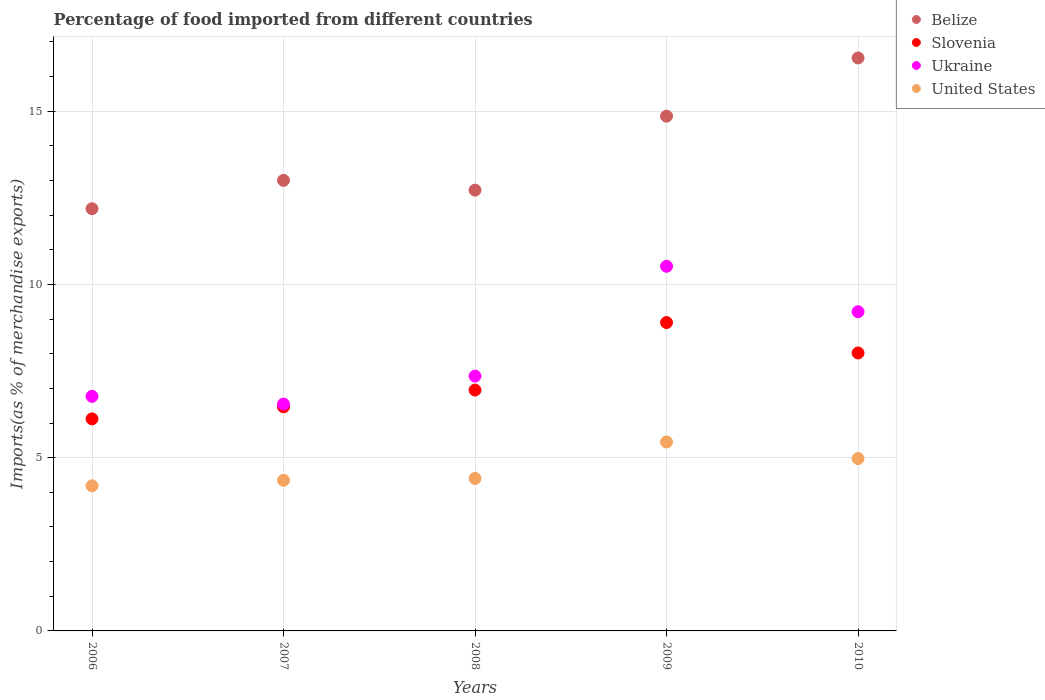Is the number of dotlines equal to the number of legend labels?
Provide a succinct answer. Yes. What is the percentage of imports to different countries in Ukraine in 2007?
Ensure brevity in your answer.  6.55. Across all years, what is the maximum percentage of imports to different countries in Slovenia?
Your answer should be compact. 8.9. Across all years, what is the minimum percentage of imports to different countries in Ukraine?
Ensure brevity in your answer.  6.55. What is the total percentage of imports to different countries in Belize in the graph?
Provide a short and direct response. 69.3. What is the difference between the percentage of imports to different countries in United States in 2006 and that in 2008?
Ensure brevity in your answer.  -0.21. What is the difference between the percentage of imports to different countries in Slovenia in 2006 and the percentage of imports to different countries in Ukraine in 2008?
Provide a succinct answer. -1.24. What is the average percentage of imports to different countries in Ukraine per year?
Provide a succinct answer. 8.08. In the year 2009, what is the difference between the percentage of imports to different countries in Ukraine and percentage of imports to different countries in Slovenia?
Provide a short and direct response. 1.62. What is the ratio of the percentage of imports to different countries in Belize in 2007 to that in 2010?
Your answer should be compact. 0.79. Is the difference between the percentage of imports to different countries in Ukraine in 2006 and 2008 greater than the difference between the percentage of imports to different countries in Slovenia in 2006 and 2008?
Offer a terse response. Yes. What is the difference between the highest and the second highest percentage of imports to different countries in Ukraine?
Offer a terse response. 1.31. What is the difference between the highest and the lowest percentage of imports to different countries in United States?
Give a very brief answer. 1.26. In how many years, is the percentage of imports to different countries in Belize greater than the average percentage of imports to different countries in Belize taken over all years?
Offer a very short reply. 2. Is the sum of the percentage of imports to different countries in United States in 2006 and 2007 greater than the maximum percentage of imports to different countries in Ukraine across all years?
Make the answer very short. No. Is the percentage of imports to different countries in United States strictly greater than the percentage of imports to different countries in Ukraine over the years?
Offer a very short reply. No. Are the values on the major ticks of Y-axis written in scientific E-notation?
Your answer should be very brief. No. How many legend labels are there?
Your answer should be very brief. 4. How are the legend labels stacked?
Make the answer very short. Vertical. What is the title of the graph?
Your answer should be compact. Percentage of food imported from different countries. What is the label or title of the Y-axis?
Provide a succinct answer. Imports(as % of merchandise exports). What is the Imports(as % of merchandise exports) of Belize in 2006?
Provide a short and direct response. 12.18. What is the Imports(as % of merchandise exports) in Slovenia in 2006?
Your answer should be very brief. 6.12. What is the Imports(as % of merchandise exports) of Ukraine in 2006?
Keep it short and to the point. 6.77. What is the Imports(as % of merchandise exports) in United States in 2006?
Keep it short and to the point. 4.19. What is the Imports(as % of merchandise exports) in Belize in 2007?
Give a very brief answer. 13. What is the Imports(as % of merchandise exports) of Slovenia in 2007?
Your answer should be very brief. 6.47. What is the Imports(as % of merchandise exports) in Ukraine in 2007?
Offer a very short reply. 6.55. What is the Imports(as % of merchandise exports) of United States in 2007?
Your answer should be very brief. 4.35. What is the Imports(as % of merchandise exports) in Belize in 2008?
Keep it short and to the point. 12.72. What is the Imports(as % of merchandise exports) in Slovenia in 2008?
Ensure brevity in your answer.  6.95. What is the Imports(as % of merchandise exports) in Ukraine in 2008?
Give a very brief answer. 7.35. What is the Imports(as % of merchandise exports) of United States in 2008?
Give a very brief answer. 4.4. What is the Imports(as % of merchandise exports) in Belize in 2009?
Your answer should be very brief. 14.86. What is the Imports(as % of merchandise exports) of Slovenia in 2009?
Make the answer very short. 8.9. What is the Imports(as % of merchandise exports) of Ukraine in 2009?
Ensure brevity in your answer.  10.52. What is the Imports(as % of merchandise exports) of United States in 2009?
Give a very brief answer. 5.45. What is the Imports(as % of merchandise exports) of Belize in 2010?
Your response must be concise. 16.54. What is the Imports(as % of merchandise exports) of Slovenia in 2010?
Keep it short and to the point. 8.02. What is the Imports(as % of merchandise exports) of Ukraine in 2010?
Provide a succinct answer. 9.21. What is the Imports(as % of merchandise exports) in United States in 2010?
Provide a succinct answer. 4.97. Across all years, what is the maximum Imports(as % of merchandise exports) in Belize?
Provide a succinct answer. 16.54. Across all years, what is the maximum Imports(as % of merchandise exports) in Slovenia?
Offer a very short reply. 8.9. Across all years, what is the maximum Imports(as % of merchandise exports) in Ukraine?
Your response must be concise. 10.52. Across all years, what is the maximum Imports(as % of merchandise exports) of United States?
Keep it short and to the point. 5.45. Across all years, what is the minimum Imports(as % of merchandise exports) in Belize?
Your answer should be very brief. 12.18. Across all years, what is the minimum Imports(as % of merchandise exports) in Slovenia?
Offer a terse response. 6.12. Across all years, what is the minimum Imports(as % of merchandise exports) in Ukraine?
Offer a terse response. 6.55. Across all years, what is the minimum Imports(as % of merchandise exports) in United States?
Give a very brief answer. 4.19. What is the total Imports(as % of merchandise exports) in Belize in the graph?
Your response must be concise. 69.3. What is the total Imports(as % of merchandise exports) of Slovenia in the graph?
Ensure brevity in your answer.  36.46. What is the total Imports(as % of merchandise exports) in Ukraine in the graph?
Ensure brevity in your answer.  40.41. What is the total Imports(as % of merchandise exports) in United States in the graph?
Offer a terse response. 23.36. What is the difference between the Imports(as % of merchandise exports) in Belize in 2006 and that in 2007?
Give a very brief answer. -0.82. What is the difference between the Imports(as % of merchandise exports) in Slovenia in 2006 and that in 2007?
Your answer should be compact. -0.35. What is the difference between the Imports(as % of merchandise exports) of Ukraine in 2006 and that in 2007?
Your answer should be very brief. 0.22. What is the difference between the Imports(as % of merchandise exports) in United States in 2006 and that in 2007?
Ensure brevity in your answer.  -0.16. What is the difference between the Imports(as % of merchandise exports) in Belize in 2006 and that in 2008?
Provide a short and direct response. -0.54. What is the difference between the Imports(as % of merchandise exports) in Slovenia in 2006 and that in 2008?
Ensure brevity in your answer.  -0.83. What is the difference between the Imports(as % of merchandise exports) of Ukraine in 2006 and that in 2008?
Your answer should be compact. -0.58. What is the difference between the Imports(as % of merchandise exports) in United States in 2006 and that in 2008?
Provide a short and direct response. -0.21. What is the difference between the Imports(as % of merchandise exports) in Belize in 2006 and that in 2009?
Offer a terse response. -2.67. What is the difference between the Imports(as % of merchandise exports) in Slovenia in 2006 and that in 2009?
Offer a terse response. -2.78. What is the difference between the Imports(as % of merchandise exports) of Ukraine in 2006 and that in 2009?
Your answer should be compact. -3.75. What is the difference between the Imports(as % of merchandise exports) in United States in 2006 and that in 2009?
Offer a very short reply. -1.26. What is the difference between the Imports(as % of merchandise exports) of Belize in 2006 and that in 2010?
Offer a terse response. -4.35. What is the difference between the Imports(as % of merchandise exports) of Slovenia in 2006 and that in 2010?
Ensure brevity in your answer.  -1.9. What is the difference between the Imports(as % of merchandise exports) in Ukraine in 2006 and that in 2010?
Your answer should be compact. -2.44. What is the difference between the Imports(as % of merchandise exports) of United States in 2006 and that in 2010?
Provide a short and direct response. -0.79. What is the difference between the Imports(as % of merchandise exports) of Belize in 2007 and that in 2008?
Provide a short and direct response. 0.28. What is the difference between the Imports(as % of merchandise exports) of Slovenia in 2007 and that in 2008?
Your response must be concise. -0.48. What is the difference between the Imports(as % of merchandise exports) in Ukraine in 2007 and that in 2008?
Offer a very short reply. -0.81. What is the difference between the Imports(as % of merchandise exports) in United States in 2007 and that in 2008?
Offer a terse response. -0.05. What is the difference between the Imports(as % of merchandise exports) of Belize in 2007 and that in 2009?
Your response must be concise. -1.85. What is the difference between the Imports(as % of merchandise exports) in Slovenia in 2007 and that in 2009?
Make the answer very short. -2.43. What is the difference between the Imports(as % of merchandise exports) of Ukraine in 2007 and that in 2009?
Offer a very short reply. -3.98. What is the difference between the Imports(as % of merchandise exports) in United States in 2007 and that in 2009?
Give a very brief answer. -1.1. What is the difference between the Imports(as % of merchandise exports) in Belize in 2007 and that in 2010?
Provide a short and direct response. -3.53. What is the difference between the Imports(as % of merchandise exports) in Slovenia in 2007 and that in 2010?
Offer a terse response. -1.56. What is the difference between the Imports(as % of merchandise exports) in Ukraine in 2007 and that in 2010?
Give a very brief answer. -2.67. What is the difference between the Imports(as % of merchandise exports) of United States in 2007 and that in 2010?
Your answer should be compact. -0.63. What is the difference between the Imports(as % of merchandise exports) of Belize in 2008 and that in 2009?
Provide a short and direct response. -2.13. What is the difference between the Imports(as % of merchandise exports) of Slovenia in 2008 and that in 2009?
Provide a succinct answer. -1.95. What is the difference between the Imports(as % of merchandise exports) of Ukraine in 2008 and that in 2009?
Provide a short and direct response. -3.17. What is the difference between the Imports(as % of merchandise exports) in United States in 2008 and that in 2009?
Your answer should be compact. -1.05. What is the difference between the Imports(as % of merchandise exports) in Belize in 2008 and that in 2010?
Your response must be concise. -3.81. What is the difference between the Imports(as % of merchandise exports) of Slovenia in 2008 and that in 2010?
Ensure brevity in your answer.  -1.07. What is the difference between the Imports(as % of merchandise exports) in Ukraine in 2008 and that in 2010?
Make the answer very short. -1.86. What is the difference between the Imports(as % of merchandise exports) in United States in 2008 and that in 2010?
Offer a very short reply. -0.57. What is the difference between the Imports(as % of merchandise exports) of Belize in 2009 and that in 2010?
Your answer should be compact. -1.68. What is the difference between the Imports(as % of merchandise exports) of Slovenia in 2009 and that in 2010?
Offer a very short reply. 0.88. What is the difference between the Imports(as % of merchandise exports) of Ukraine in 2009 and that in 2010?
Ensure brevity in your answer.  1.31. What is the difference between the Imports(as % of merchandise exports) in United States in 2009 and that in 2010?
Provide a succinct answer. 0.48. What is the difference between the Imports(as % of merchandise exports) in Belize in 2006 and the Imports(as % of merchandise exports) in Slovenia in 2007?
Provide a succinct answer. 5.72. What is the difference between the Imports(as % of merchandise exports) of Belize in 2006 and the Imports(as % of merchandise exports) of Ukraine in 2007?
Keep it short and to the point. 5.64. What is the difference between the Imports(as % of merchandise exports) in Belize in 2006 and the Imports(as % of merchandise exports) in United States in 2007?
Provide a short and direct response. 7.84. What is the difference between the Imports(as % of merchandise exports) of Slovenia in 2006 and the Imports(as % of merchandise exports) of Ukraine in 2007?
Your answer should be very brief. -0.43. What is the difference between the Imports(as % of merchandise exports) of Slovenia in 2006 and the Imports(as % of merchandise exports) of United States in 2007?
Offer a terse response. 1.77. What is the difference between the Imports(as % of merchandise exports) of Ukraine in 2006 and the Imports(as % of merchandise exports) of United States in 2007?
Offer a terse response. 2.42. What is the difference between the Imports(as % of merchandise exports) in Belize in 2006 and the Imports(as % of merchandise exports) in Slovenia in 2008?
Offer a very short reply. 5.23. What is the difference between the Imports(as % of merchandise exports) in Belize in 2006 and the Imports(as % of merchandise exports) in Ukraine in 2008?
Give a very brief answer. 4.83. What is the difference between the Imports(as % of merchandise exports) of Belize in 2006 and the Imports(as % of merchandise exports) of United States in 2008?
Provide a short and direct response. 7.78. What is the difference between the Imports(as % of merchandise exports) in Slovenia in 2006 and the Imports(as % of merchandise exports) in Ukraine in 2008?
Your answer should be very brief. -1.24. What is the difference between the Imports(as % of merchandise exports) of Slovenia in 2006 and the Imports(as % of merchandise exports) of United States in 2008?
Provide a succinct answer. 1.72. What is the difference between the Imports(as % of merchandise exports) in Ukraine in 2006 and the Imports(as % of merchandise exports) in United States in 2008?
Your answer should be very brief. 2.37. What is the difference between the Imports(as % of merchandise exports) in Belize in 2006 and the Imports(as % of merchandise exports) in Slovenia in 2009?
Provide a short and direct response. 3.29. What is the difference between the Imports(as % of merchandise exports) in Belize in 2006 and the Imports(as % of merchandise exports) in Ukraine in 2009?
Your answer should be very brief. 1.66. What is the difference between the Imports(as % of merchandise exports) of Belize in 2006 and the Imports(as % of merchandise exports) of United States in 2009?
Make the answer very short. 6.73. What is the difference between the Imports(as % of merchandise exports) in Slovenia in 2006 and the Imports(as % of merchandise exports) in Ukraine in 2009?
Give a very brief answer. -4.4. What is the difference between the Imports(as % of merchandise exports) in Slovenia in 2006 and the Imports(as % of merchandise exports) in United States in 2009?
Your answer should be compact. 0.67. What is the difference between the Imports(as % of merchandise exports) of Ukraine in 2006 and the Imports(as % of merchandise exports) of United States in 2009?
Your response must be concise. 1.32. What is the difference between the Imports(as % of merchandise exports) in Belize in 2006 and the Imports(as % of merchandise exports) in Slovenia in 2010?
Make the answer very short. 4.16. What is the difference between the Imports(as % of merchandise exports) of Belize in 2006 and the Imports(as % of merchandise exports) of Ukraine in 2010?
Provide a short and direct response. 2.97. What is the difference between the Imports(as % of merchandise exports) in Belize in 2006 and the Imports(as % of merchandise exports) in United States in 2010?
Give a very brief answer. 7.21. What is the difference between the Imports(as % of merchandise exports) in Slovenia in 2006 and the Imports(as % of merchandise exports) in Ukraine in 2010?
Make the answer very short. -3.09. What is the difference between the Imports(as % of merchandise exports) of Slovenia in 2006 and the Imports(as % of merchandise exports) of United States in 2010?
Your answer should be very brief. 1.15. What is the difference between the Imports(as % of merchandise exports) in Ukraine in 2006 and the Imports(as % of merchandise exports) in United States in 2010?
Your response must be concise. 1.8. What is the difference between the Imports(as % of merchandise exports) in Belize in 2007 and the Imports(as % of merchandise exports) in Slovenia in 2008?
Your response must be concise. 6.05. What is the difference between the Imports(as % of merchandise exports) in Belize in 2007 and the Imports(as % of merchandise exports) in Ukraine in 2008?
Provide a short and direct response. 5.65. What is the difference between the Imports(as % of merchandise exports) of Belize in 2007 and the Imports(as % of merchandise exports) of United States in 2008?
Keep it short and to the point. 8.6. What is the difference between the Imports(as % of merchandise exports) of Slovenia in 2007 and the Imports(as % of merchandise exports) of Ukraine in 2008?
Your answer should be compact. -0.89. What is the difference between the Imports(as % of merchandise exports) in Slovenia in 2007 and the Imports(as % of merchandise exports) in United States in 2008?
Make the answer very short. 2.07. What is the difference between the Imports(as % of merchandise exports) of Ukraine in 2007 and the Imports(as % of merchandise exports) of United States in 2008?
Give a very brief answer. 2.15. What is the difference between the Imports(as % of merchandise exports) of Belize in 2007 and the Imports(as % of merchandise exports) of Slovenia in 2009?
Keep it short and to the point. 4.1. What is the difference between the Imports(as % of merchandise exports) in Belize in 2007 and the Imports(as % of merchandise exports) in Ukraine in 2009?
Make the answer very short. 2.48. What is the difference between the Imports(as % of merchandise exports) in Belize in 2007 and the Imports(as % of merchandise exports) in United States in 2009?
Provide a succinct answer. 7.55. What is the difference between the Imports(as % of merchandise exports) in Slovenia in 2007 and the Imports(as % of merchandise exports) in Ukraine in 2009?
Your answer should be compact. -4.06. What is the difference between the Imports(as % of merchandise exports) in Slovenia in 2007 and the Imports(as % of merchandise exports) in United States in 2009?
Keep it short and to the point. 1.02. What is the difference between the Imports(as % of merchandise exports) of Ukraine in 2007 and the Imports(as % of merchandise exports) of United States in 2009?
Make the answer very short. 1.09. What is the difference between the Imports(as % of merchandise exports) of Belize in 2007 and the Imports(as % of merchandise exports) of Slovenia in 2010?
Provide a short and direct response. 4.98. What is the difference between the Imports(as % of merchandise exports) of Belize in 2007 and the Imports(as % of merchandise exports) of Ukraine in 2010?
Your response must be concise. 3.79. What is the difference between the Imports(as % of merchandise exports) of Belize in 2007 and the Imports(as % of merchandise exports) of United States in 2010?
Make the answer very short. 8.03. What is the difference between the Imports(as % of merchandise exports) of Slovenia in 2007 and the Imports(as % of merchandise exports) of Ukraine in 2010?
Offer a terse response. -2.75. What is the difference between the Imports(as % of merchandise exports) in Slovenia in 2007 and the Imports(as % of merchandise exports) in United States in 2010?
Your answer should be compact. 1.49. What is the difference between the Imports(as % of merchandise exports) in Ukraine in 2007 and the Imports(as % of merchandise exports) in United States in 2010?
Offer a very short reply. 1.57. What is the difference between the Imports(as % of merchandise exports) of Belize in 2008 and the Imports(as % of merchandise exports) of Slovenia in 2009?
Provide a short and direct response. 3.82. What is the difference between the Imports(as % of merchandise exports) of Belize in 2008 and the Imports(as % of merchandise exports) of Ukraine in 2009?
Ensure brevity in your answer.  2.2. What is the difference between the Imports(as % of merchandise exports) of Belize in 2008 and the Imports(as % of merchandise exports) of United States in 2009?
Offer a terse response. 7.27. What is the difference between the Imports(as % of merchandise exports) in Slovenia in 2008 and the Imports(as % of merchandise exports) in Ukraine in 2009?
Your answer should be very brief. -3.57. What is the difference between the Imports(as % of merchandise exports) of Slovenia in 2008 and the Imports(as % of merchandise exports) of United States in 2009?
Provide a short and direct response. 1.5. What is the difference between the Imports(as % of merchandise exports) in Ukraine in 2008 and the Imports(as % of merchandise exports) in United States in 2009?
Provide a short and direct response. 1.9. What is the difference between the Imports(as % of merchandise exports) of Belize in 2008 and the Imports(as % of merchandise exports) of Slovenia in 2010?
Ensure brevity in your answer.  4.7. What is the difference between the Imports(as % of merchandise exports) of Belize in 2008 and the Imports(as % of merchandise exports) of Ukraine in 2010?
Your answer should be very brief. 3.51. What is the difference between the Imports(as % of merchandise exports) in Belize in 2008 and the Imports(as % of merchandise exports) in United States in 2010?
Make the answer very short. 7.75. What is the difference between the Imports(as % of merchandise exports) of Slovenia in 2008 and the Imports(as % of merchandise exports) of Ukraine in 2010?
Offer a very short reply. -2.26. What is the difference between the Imports(as % of merchandise exports) of Slovenia in 2008 and the Imports(as % of merchandise exports) of United States in 2010?
Your response must be concise. 1.98. What is the difference between the Imports(as % of merchandise exports) in Ukraine in 2008 and the Imports(as % of merchandise exports) in United States in 2010?
Offer a very short reply. 2.38. What is the difference between the Imports(as % of merchandise exports) of Belize in 2009 and the Imports(as % of merchandise exports) of Slovenia in 2010?
Offer a terse response. 6.83. What is the difference between the Imports(as % of merchandise exports) in Belize in 2009 and the Imports(as % of merchandise exports) in Ukraine in 2010?
Provide a short and direct response. 5.64. What is the difference between the Imports(as % of merchandise exports) in Belize in 2009 and the Imports(as % of merchandise exports) in United States in 2010?
Offer a terse response. 9.88. What is the difference between the Imports(as % of merchandise exports) of Slovenia in 2009 and the Imports(as % of merchandise exports) of Ukraine in 2010?
Provide a succinct answer. -0.31. What is the difference between the Imports(as % of merchandise exports) in Slovenia in 2009 and the Imports(as % of merchandise exports) in United States in 2010?
Offer a very short reply. 3.93. What is the difference between the Imports(as % of merchandise exports) of Ukraine in 2009 and the Imports(as % of merchandise exports) of United States in 2010?
Provide a succinct answer. 5.55. What is the average Imports(as % of merchandise exports) in Belize per year?
Your answer should be compact. 13.86. What is the average Imports(as % of merchandise exports) of Slovenia per year?
Provide a short and direct response. 7.29. What is the average Imports(as % of merchandise exports) in Ukraine per year?
Offer a very short reply. 8.08. What is the average Imports(as % of merchandise exports) of United States per year?
Your response must be concise. 4.67. In the year 2006, what is the difference between the Imports(as % of merchandise exports) of Belize and Imports(as % of merchandise exports) of Slovenia?
Ensure brevity in your answer.  6.07. In the year 2006, what is the difference between the Imports(as % of merchandise exports) of Belize and Imports(as % of merchandise exports) of Ukraine?
Provide a short and direct response. 5.41. In the year 2006, what is the difference between the Imports(as % of merchandise exports) in Belize and Imports(as % of merchandise exports) in United States?
Offer a very short reply. 8. In the year 2006, what is the difference between the Imports(as % of merchandise exports) of Slovenia and Imports(as % of merchandise exports) of Ukraine?
Provide a succinct answer. -0.65. In the year 2006, what is the difference between the Imports(as % of merchandise exports) in Slovenia and Imports(as % of merchandise exports) in United States?
Your answer should be very brief. 1.93. In the year 2006, what is the difference between the Imports(as % of merchandise exports) in Ukraine and Imports(as % of merchandise exports) in United States?
Your answer should be compact. 2.58. In the year 2007, what is the difference between the Imports(as % of merchandise exports) in Belize and Imports(as % of merchandise exports) in Slovenia?
Ensure brevity in your answer.  6.54. In the year 2007, what is the difference between the Imports(as % of merchandise exports) of Belize and Imports(as % of merchandise exports) of Ukraine?
Give a very brief answer. 6.46. In the year 2007, what is the difference between the Imports(as % of merchandise exports) in Belize and Imports(as % of merchandise exports) in United States?
Offer a terse response. 8.66. In the year 2007, what is the difference between the Imports(as % of merchandise exports) in Slovenia and Imports(as % of merchandise exports) in Ukraine?
Give a very brief answer. -0.08. In the year 2007, what is the difference between the Imports(as % of merchandise exports) of Slovenia and Imports(as % of merchandise exports) of United States?
Your response must be concise. 2.12. In the year 2007, what is the difference between the Imports(as % of merchandise exports) of Ukraine and Imports(as % of merchandise exports) of United States?
Your answer should be very brief. 2.2. In the year 2008, what is the difference between the Imports(as % of merchandise exports) of Belize and Imports(as % of merchandise exports) of Slovenia?
Offer a very short reply. 5.77. In the year 2008, what is the difference between the Imports(as % of merchandise exports) of Belize and Imports(as % of merchandise exports) of Ukraine?
Offer a very short reply. 5.37. In the year 2008, what is the difference between the Imports(as % of merchandise exports) in Belize and Imports(as % of merchandise exports) in United States?
Ensure brevity in your answer.  8.32. In the year 2008, what is the difference between the Imports(as % of merchandise exports) in Slovenia and Imports(as % of merchandise exports) in Ukraine?
Offer a very short reply. -0.4. In the year 2008, what is the difference between the Imports(as % of merchandise exports) in Slovenia and Imports(as % of merchandise exports) in United States?
Make the answer very short. 2.55. In the year 2008, what is the difference between the Imports(as % of merchandise exports) of Ukraine and Imports(as % of merchandise exports) of United States?
Ensure brevity in your answer.  2.95. In the year 2009, what is the difference between the Imports(as % of merchandise exports) in Belize and Imports(as % of merchandise exports) in Slovenia?
Provide a short and direct response. 5.96. In the year 2009, what is the difference between the Imports(as % of merchandise exports) of Belize and Imports(as % of merchandise exports) of Ukraine?
Provide a short and direct response. 4.33. In the year 2009, what is the difference between the Imports(as % of merchandise exports) of Belize and Imports(as % of merchandise exports) of United States?
Keep it short and to the point. 9.4. In the year 2009, what is the difference between the Imports(as % of merchandise exports) in Slovenia and Imports(as % of merchandise exports) in Ukraine?
Your response must be concise. -1.62. In the year 2009, what is the difference between the Imports(as % of merchandise exports) in Slovenia and Imports(as % of merchandise exports) in United States?
Offer a terse response. 3.45. In the year 2009, what is the difference between the Imports(as % of merchandise exports) in Ukraine and Imports(as % of merchandise exports) in United States?
Offer a terse response. 5.07. In the year 2010, what is the difference between the Imports(as % of merchandise exports) in Belize and Imports(as % of merchandise exports) in Slovenia?
Offer a terse response. 8.51. In the year 2010, what is the difference between the Imports(as % of merchandise exports) in Belize and Imports(as % of merchandise exports) in Ukraine?
Your answer should be very brief. 7.32. In the year 2010, what is the difference between the Imports(as % of merchandise exports) of Belize and Imports(as % of merchandise exports) of United States?
Your response must be concise. 11.56. In the year 2010, what is the difference between the Imports(as % of merchandise exports) in Slovenia and Imports(as % of merchandise exports) in Ukraine?
Keep it short and to the point. -1.19. In the year 2010, what is the difference between the Imports(as % of merchandise exports) of Slovenia and Imports(as % of merchandise exports) of United States?
Give a very brief answer. 3.05. In the year 2010, what is the difference between the Imports(as % of merchandise exports) in Ukraine and Imports(as % of merchandise exports) in United States?
Provide a succinct answer. 4.24. What is the ratio of the Imports(as % of merchandise exports) in Belize in 2006 to that in 2007?
Make the answer very short. 0.94. What is the ratio of the Imports(as % of merchandise exports) of Slovenia in 2006 to that in 2007?
Provide a short and direct response. 0.95. What is the ratio of the Imports(as % of merchandise exports) in Ukraine in 2006 to that in 2007?
Provide a short and direct response. 1.03. What is the ratio of the Imports(as % of merchandise exports) of United States in 2006 to that in 2007?
Offer a terse response. 0.96. What is the ratio of the Imports(as % of merchandise exports) of Belize in 2006 to that in 2008?
Give a very brief answer. 0.96. What is the ratio of the Imports(as % of merchandise exports) in Slovenia in 2006 to that in 2008?
Make the answer very short. 0.88. What is the ratio of the Imports(as % of merchandise exports) in Ukraine in 2006 to that in 2008?
Provide a short and direct response. 0.92. What is the ratio of the Imports(as % of merchandise exports) of United States in 2006 to that in 2008?
Offer a terse response. 0.95. What is the ratio of the Imports(as % of merchandise exports) of Belize in 2006 to that in 2009?
Your answer should be compact. 0.82. What is the ratio of the Imports(as % of merchandise exports) in Slovenia in 2006 to that in 2009?
Offer a terse response. 0.69. What is the ratio of the Imports(as % of merchandise exports) in Ukraine in 2006 to that in 2009?
Ensure brevity in your answer.  0.64. What is the ratio of the Imports(as % of merchandise exports) of United States in 2006 to that in 2009?
Your answer should be very brief. 0.77. What is the ratio of the Imports(as % of merchandise exports) of Belize in 2006 to that in 2010?
Keep it short and to the point. 0.74. What is the ratio of the Imports(as % of merchandise exports) of Slovenia in 2006 to that in 2010?
Offer a very short reply. 0.76. What is the ratio of the Imports(as % of merchandise exports) in Ukraine in 2006 to that in 2010?
Provide a succinct answer. 0.73. What is the ratio of the Imports(as % of merchandise exports) in United States in 2006 to that in 2010?
Your response must be concise. 0.84. What is the ratio of the Imports(as % of merchandise exports) of Belize in 2007 to that in 2008?
Offer a terse response. 1.02. What is the ratio of the Imports(as % of merchandise exports) in Slovenia in 2007 to that in 2008?
Your answer should be compact. 0.93. What is the ratio of the Imports(as % of merchandise exports) of Ukraine in 2007 to that in 2008?
Your answer should be very brief. 0.89. What is the ratio of the Imports(as % of merchandise exports) of Belize in 2007 to that in 2009?
Give a very brief answer. 0.88. What is the ratio of the Imports(as % of merchandise exports) of Slovenia in 2007 to that in 2009?
Provide a succinct answer. 0.73. What is the ratio of the Imports(as % of merchandise exports) in Ukraine in 2007 to that in 2009?
Your answer should be compact. 0.62. What is the ratio of the Imports(as % of merchandise exports) of United States in 2007 to that in 2009?
Make the answer very short. 0.8. What is the ratio of the Imports(as % of merchandise exports) of Belize in 2007 to that in 2010?
Give a very brief answer. 0.79. What is the ratio of the Imports(as % of merchandise exports) in Slovenia in 2007 to that in 2010?
Give a very brief answer. 0.81. What is the ratio of the Imports(as % of merchandise exports) of Ukraine in 2007 to that in 2010?
Keep it short and to the point. 0.71. What is the ratio of the Imports(as % of merchandise exports) in United States in 2007 to that in 2010?
Offer a very short reply. 0.87. What is the ratio of the Imports(as % of merchandise exports) in Belize in 2008 to that in 2009?
Offer a terse response. 0.86. What is the ratio of the Imports(as % of merchandise exports) in Slovenia in 2008 to that in 2009?
Offer a terse response. 0.78. What is the ratio of the Imports(as % of merchandise exports) of Ukraine in 2008 to that in 2009?
Your answer should be compact. 0.7. What is the ratio of the Imports(as % of merchandise exports) of United States in 2008 to that in 2009?
Your answer should be very brief. 0.81. What is the ratio of the Imports(as % of merchandise exports) in Belize in 2008 to that in 2010?
Ensure brevity in your answer.  0.77. What is the ratio of the Imports(as % of merchandise exports) in Slovenia in 2008 to that in 2010?
Provide a succinct answer. 0.87. What is the ratio of the Imports(as % of merchandise exports) in Ukraine in 2008 to that in 2010?
Make the answer very short. 0.8. What is the ratio of the Imports(as % of merchandise exports) in United States in 2008 to that in 2010?
Provide a succinct answer. 0.88. What is the ratio of the Imports(as % of merchandise exports) in Belize in 2009 to that in 2010?
Provide a short and direct response. 0.9. What is the ratio of the Imports(as % of merchandise exports) in Slovenia in 2009 to that in 2010?
Your answer should be compact. 1.11. What is the ratio of the Imports(as % of merchandise exports) of Ukraine in 2009 to that in 2010?
Ensure brevity in your answer.  1.14. What is the ratio of the Imports(as % of merchandise exports) in United States in 2009 to that in 2010?
Offer a terse response. 1.1. What is the difference between the highest and the second highest Imports(as % of merchandise exports) of Belize?
Your response must be concise. 1.68. What is the difference between the highest and the second highest Imports(as % of merchandise exports) in Slovenia?
Your answer should be compact. 0.88. What is the difference between the highest and the second highest Imports(as % of merchandise exports) of Ukraine?
Provide a succinct answer. 1.31. What is the difference between the highest and the second highest Imports(as % of merchandise exports) of United States?
Make the answer very short. 0.48. What is the difference between the highest and the lowest Imports(as % of merchandise exports) in Belize?
Make the answer very short. 4.35. What is the difference between the highest and the lowest Imports(as % of merchandise exports) in Slovenia?
Your answer should be very brief. 2.78. What is the difference between the highest and the lowest Imports(as % of merchandise exports) in Ukraine?
Provide a short and direct response. 3.98. What is the difference between the highest and the lowest Imports(as % of merchandise exports) in United States?
Your response must be concise. 1.26. 